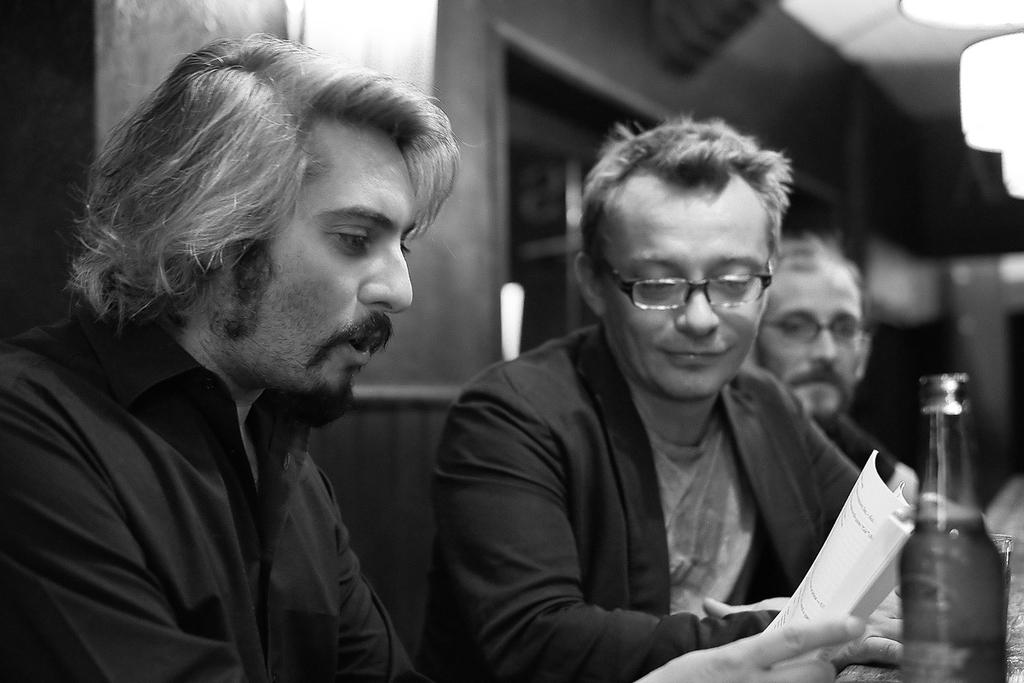How many men are sitting in the image? There are three men sitting in the image. What is one of the men holding in his hand? One of the men is holding a paper in his hand. What can be seen besides the men in the image? There is a bottle and a glass visible in the image. What is visible in the background of the image? There is a wall visible in the background of the image. What type of cord is being used by the men in the image? There is no cord visible in the image. What do the men believe about the paper they are holding? The image does not provide any information about the men's beliefs regarding the paper they are holding. 